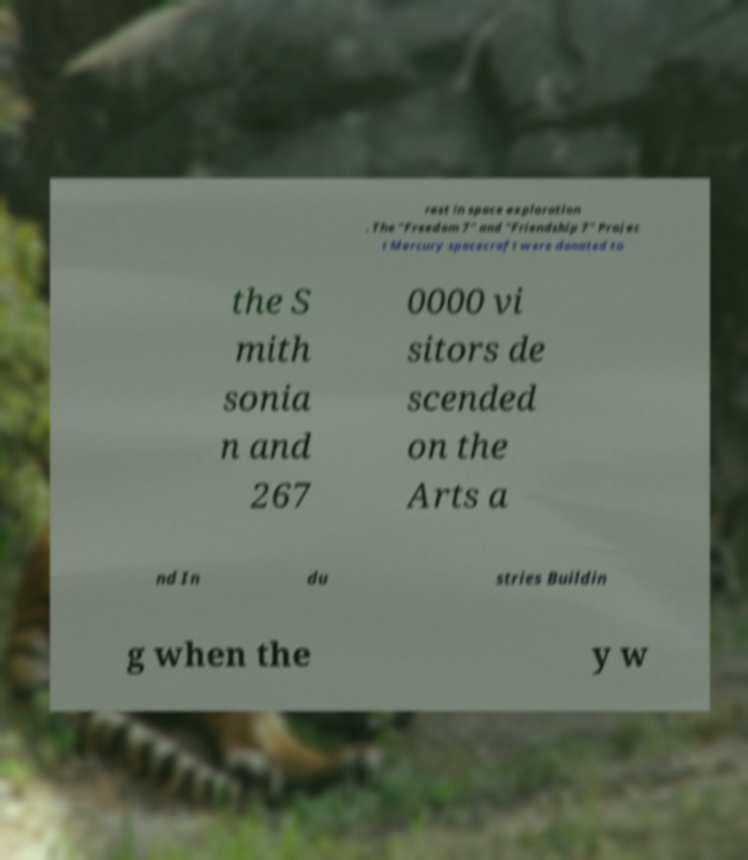Can you accurately transcribe the text from the provided image for me? rest in space exploration . The "Freedom 7" and "Friendship 7" Projec t Mercury spacecraft were donated to the S mith sonia n and 267 0000 vi sitors de scended on the Arts a nd In du stries Buildin g when the y w 